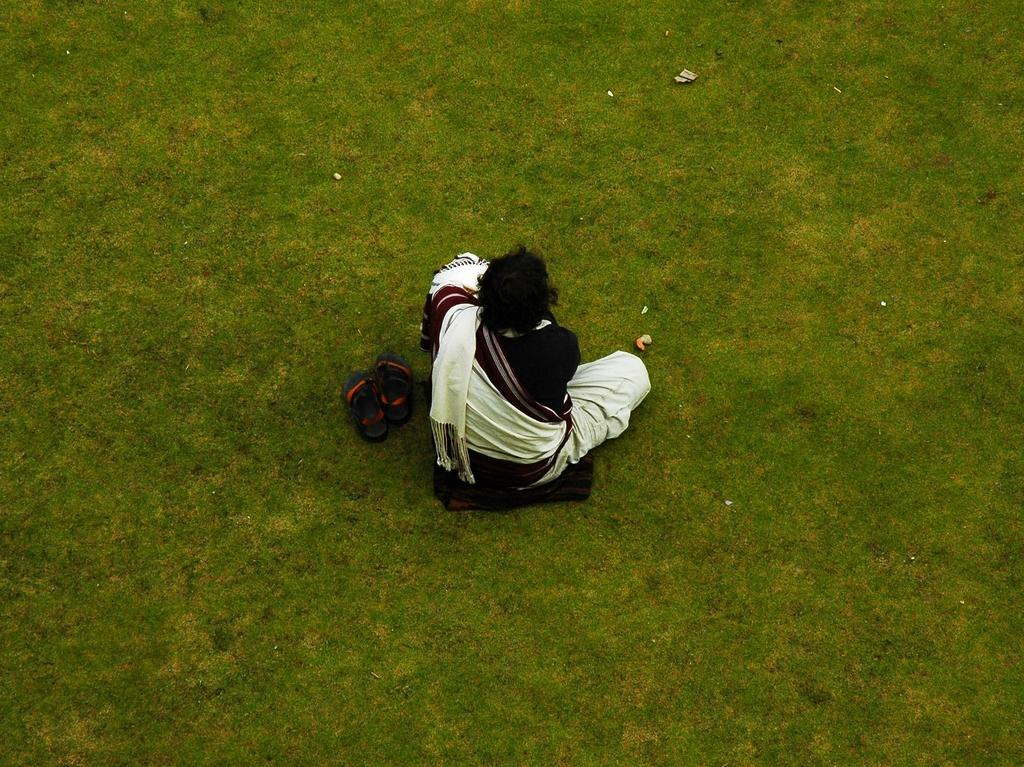What is the person sitting on in the image? The person is sitting on cloth. Where is the person sitting in relation to the grass? The person is sitting on the grass. What else can be seen on the grass in the image? There is footwear on the grass. What type of wheel is visible in the image? There is no wheel present in the image. Can you tell me the name of the minister in the image? There is no minister present in the image. 